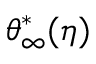<formula> <loc_0><loc_0><loc_500><loc_500>{ \theta } _ { \infty } ^ { * } ( \eta )</formula> 